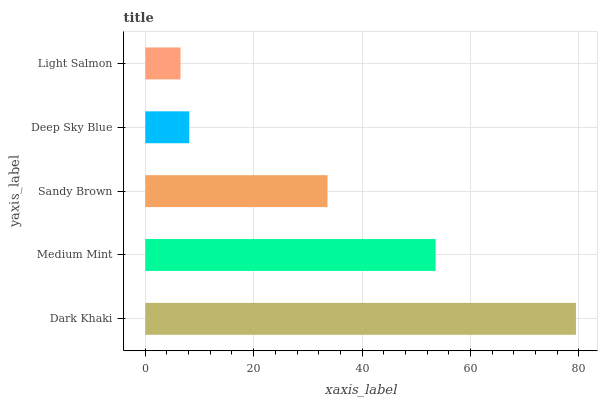Is Light Salmon the minimum?
Answer yes or no. Yes. Is Dark Khaki the maximum?
Answer yes or no. Yes. Is Medium Mint the minimum?
Answer yes or no. No. Is Medium Mint the maximum?
Answer yes or no. No. Is Dark Khaki greater than Medium Mint?
Answer yes or no. Yes. Is Medium Mint less than Dark Khaki?
Answer yes or no. Yes. Is Medium Mint greater than Dark Khaki?
Answer yes or no. No. Is Dark Khaki less than Medium Mint?
Answer yes or no. No. Is Sandy Brown the high median?
Answer yes or no. Yes. Is Sandy Brown the low median?
Answer yes or no. Yes. Is Medium Mint the high median?
Answer yes or no. No. Is Dark Khaki the low median?
Answer yes or no. No. 